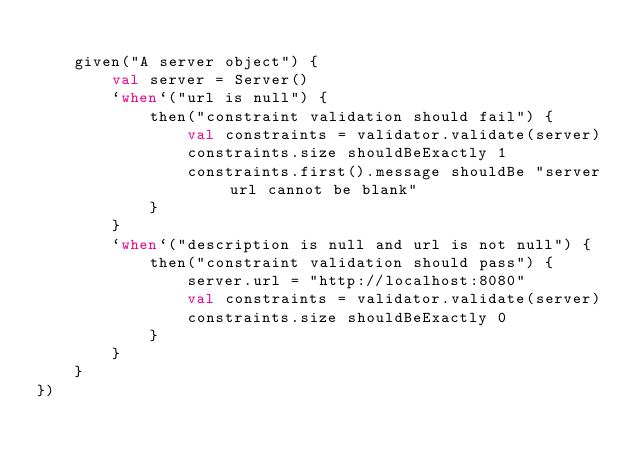<code> <loc_0><loc_0><loc_500><loc_500><_Kotlin_>
    given("A server object") {
        val server = Server()
        `when`("url is null") {
            then("constraint validation should fail") {
                val constraints = validator.validate(server)
                constraints.size shouldBeExactly 1
                constraints.first().message shouldBe "server url cannot be blank"
            }
        }
        `when`("description is null and url is not null") {
            then("constraint validation should pass") {
                server.url = "http://localhost:8080"
                val constraints = validator.validate(server)
                constraints.size shouldBeExactly 0
            }
        }
    }
})</code> 